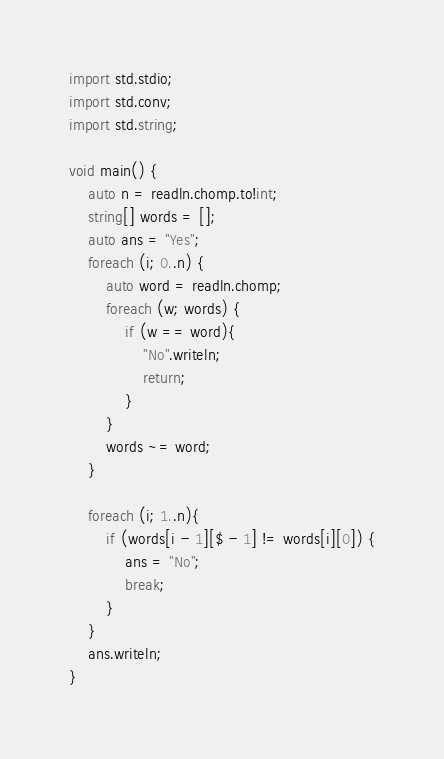Convert code to text. <code><loc_0><loc_0><loc_500><loc_500><_D_>import std.stdio;
import std.conv;
import std.string;

void main() {
    auto n = readln.chomp.to!int;
    string[] words = [];
    auto ans = "Yes";
    foreach (i; 0..n) {
        auto word = readln.chomp;
        foreach (w; words) {
            if (w == word){
                "No".writeln;
                return;
            }
        }
        words ~= word;
    }

    foreach (i; 1..n){
        if (words[i - 1][$ - 1] != words[i][0]) {
            ans = "No";
            break;
        }
    }
    ans.writeln;
}
</code> 